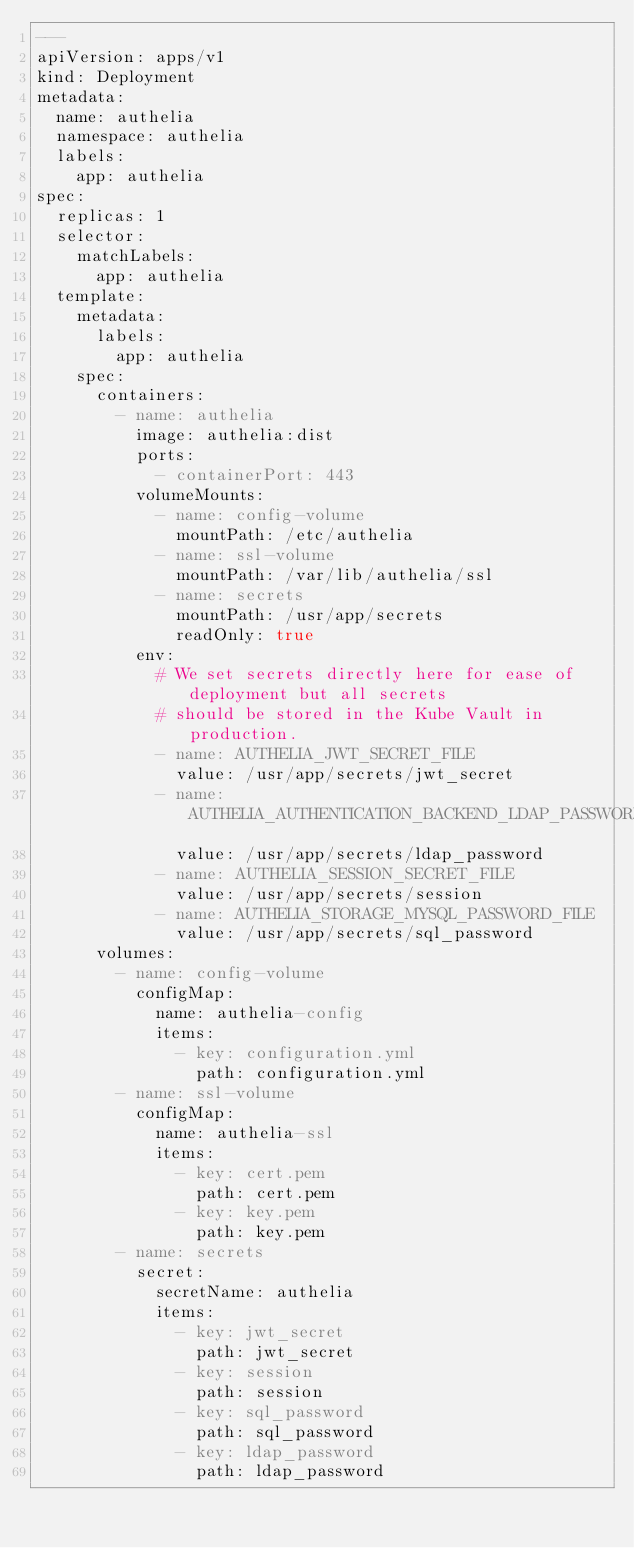Convert code to text. <code><loc_0><loc_0><loc_500><loc_500><_YAML_>---
apiVersion: apps/v1
kind: Deployment
metadata:
  name: authelia
  namespace: authelia
  labels:
    app: authelia
spec:
  replicas: 1
  selector:
    matchLabels:
      app: authelia
  template:
    metadata:
      labels:
        app: authelia
    spec:
      containers:
        - name: authelia
          image: authelia:dist
          ports:
            - containerPort: 443
          volumeMounts:
            - name: config-volume
              mountPath: /etc/authelia
            - name: ssl-volume
              mountPath: /var/lib/authelia/ssl
            - name: secrets
              mountPath: /usr/app/secrets
              readOnly: true
          env:
            # We set secrets directly here for ease of deployment but all secrets
            # should be stored in the Kube Vault in production.
            - name: AUTHELIA_JWT_SECRET_FILE
              value: /usr/app/secrets/jwt_secret
            - name: AUTHELIA_AUTHENTICATION_BACKEND_LDAP_PASSWORD_FILE
              value: /usr/app/secrets/ldap_password
            - name: AUTHELIA_SESSION_SECRET_FILE
              value: /usr/app/secrets/session
            - name: AUTHELIA_STORAGE_MYSQL_PASSWORD_FILE
              value: /usr/app/secrets/sql_password
      volumes:
        - name: config-volume
          configMap:
            name: authelia-config
            items:
              - key: configuration.yml
                path: configuration.yml
        - name: ssl-volume
          configMap:
            name: authelia-ssl
            items:
              - key: cert.pem
                path: cert.pem
              - key: key.pem
                path: key.pem
        - name: secrets
          secret:
            secretName: authelia
            items:
              - key: jwt_secret
                path: jwt_secret
              - key: session
                path: session
              - key: sql_password
                path: sql_password
              - key: ldap_password
                path: ldap_password</code> 